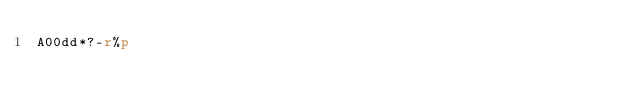Convert code to text. <code><loc_0><loc_0><loc_500><loc_500><_dc_>A00dd*?-r%p</code> 